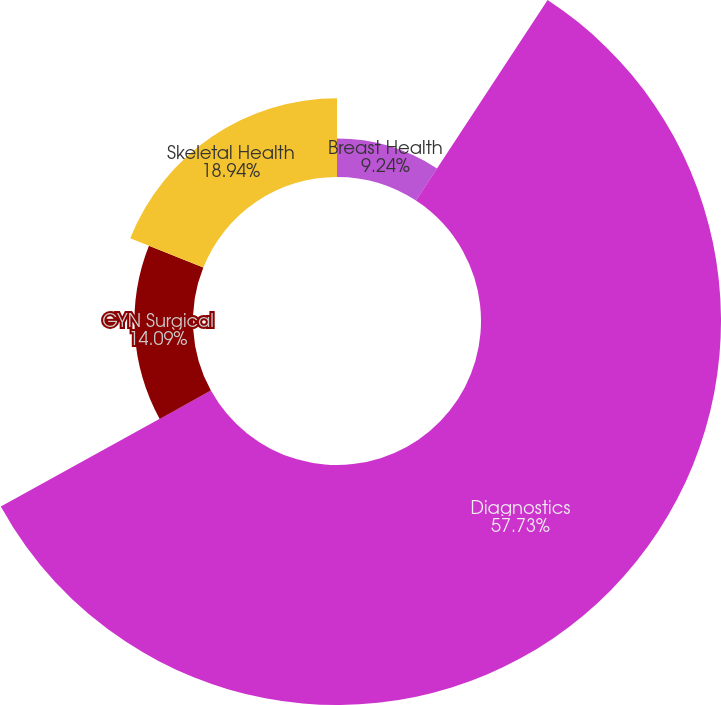Convert chart to OTSL. <chart><loc_0><loc_0><loc_500><loc_500><pie_chart><fcel>Breast Health<fcel>Diagnostics<fcel>GYN Surgical<fcel>Skeletal Health<nl><fcel>9.24%<fcel>57.74%<fcel>14.09%<fcel>18.94%<nl></chart> 